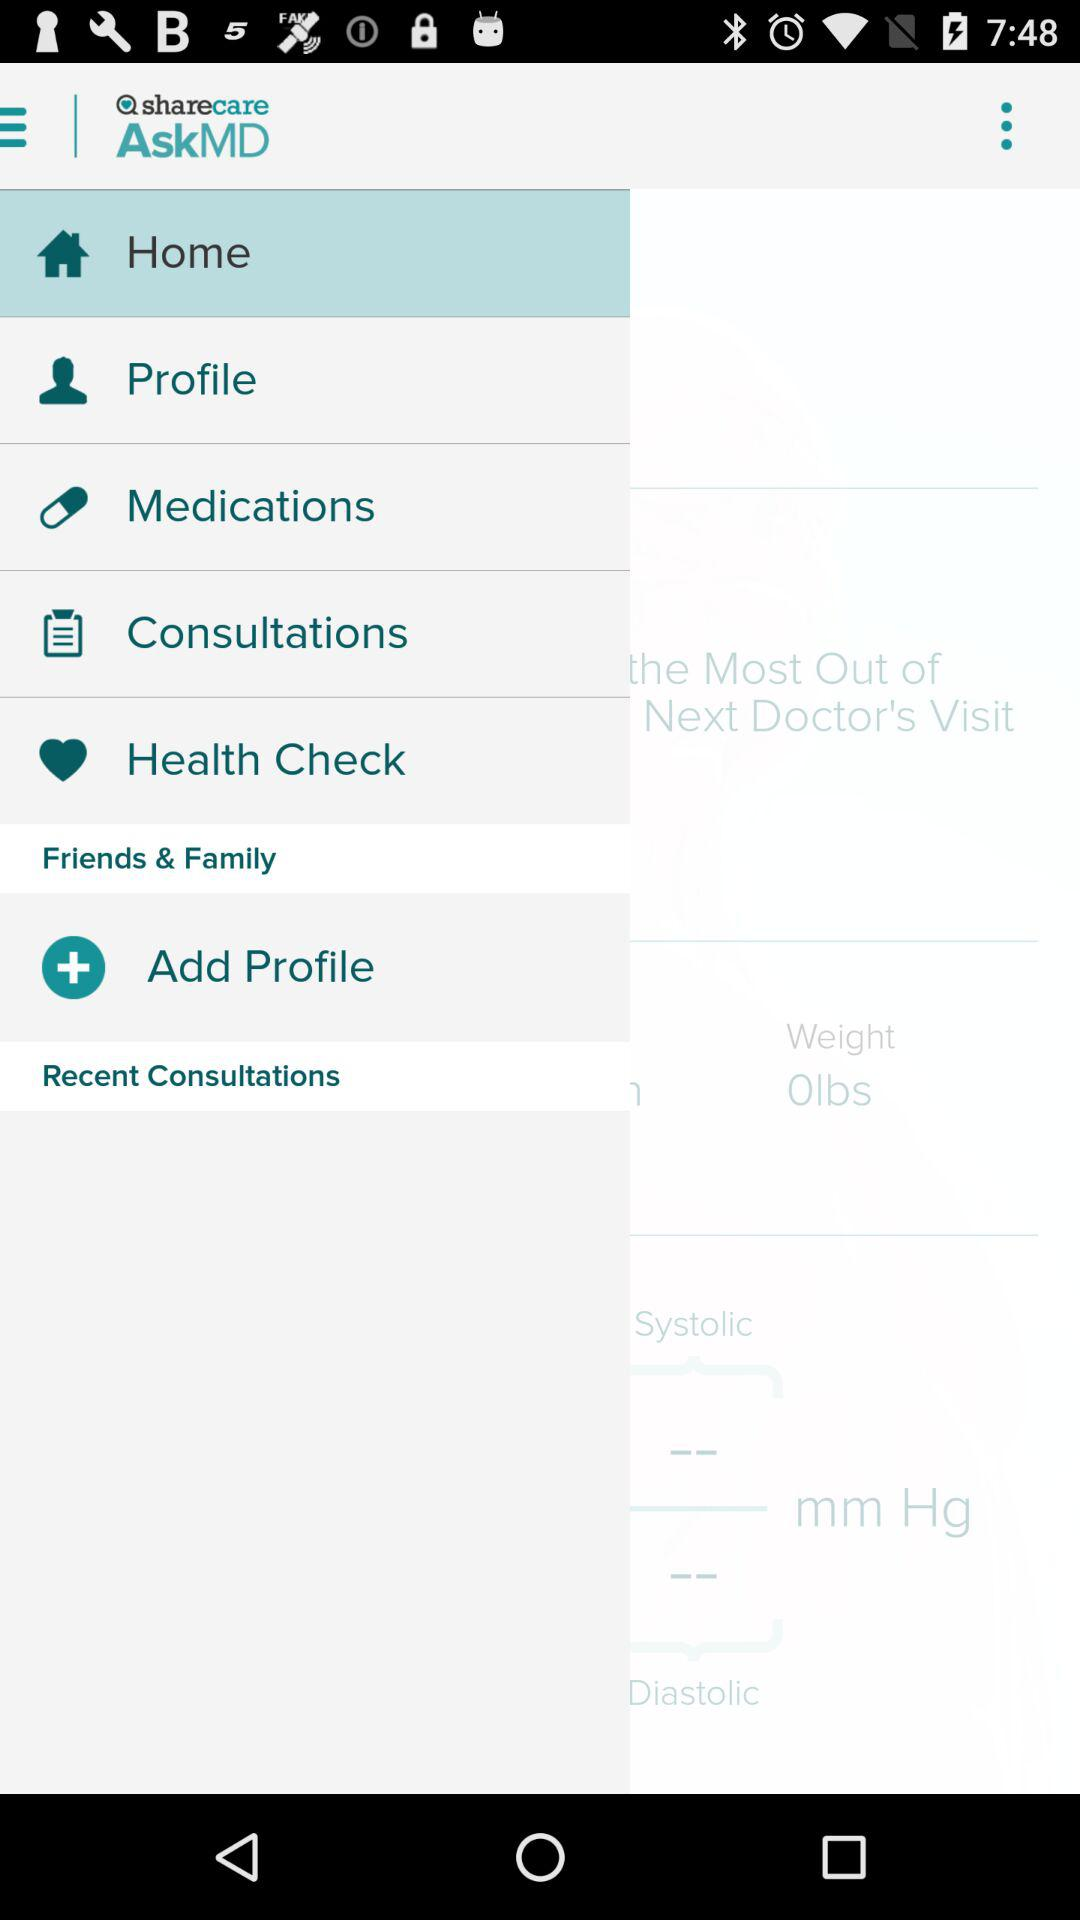Which option has been selected? The selected option is "Home". 